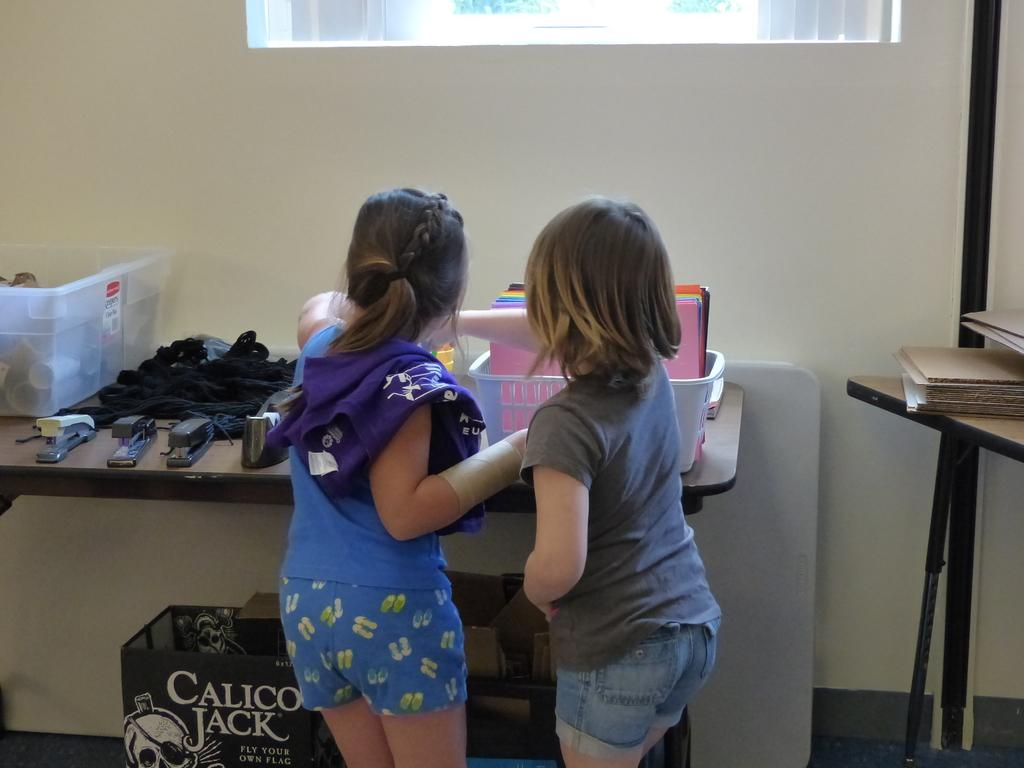<image>
Summarize the visual content of the image. a couple of kids next to a Calico Jack box on the ground 